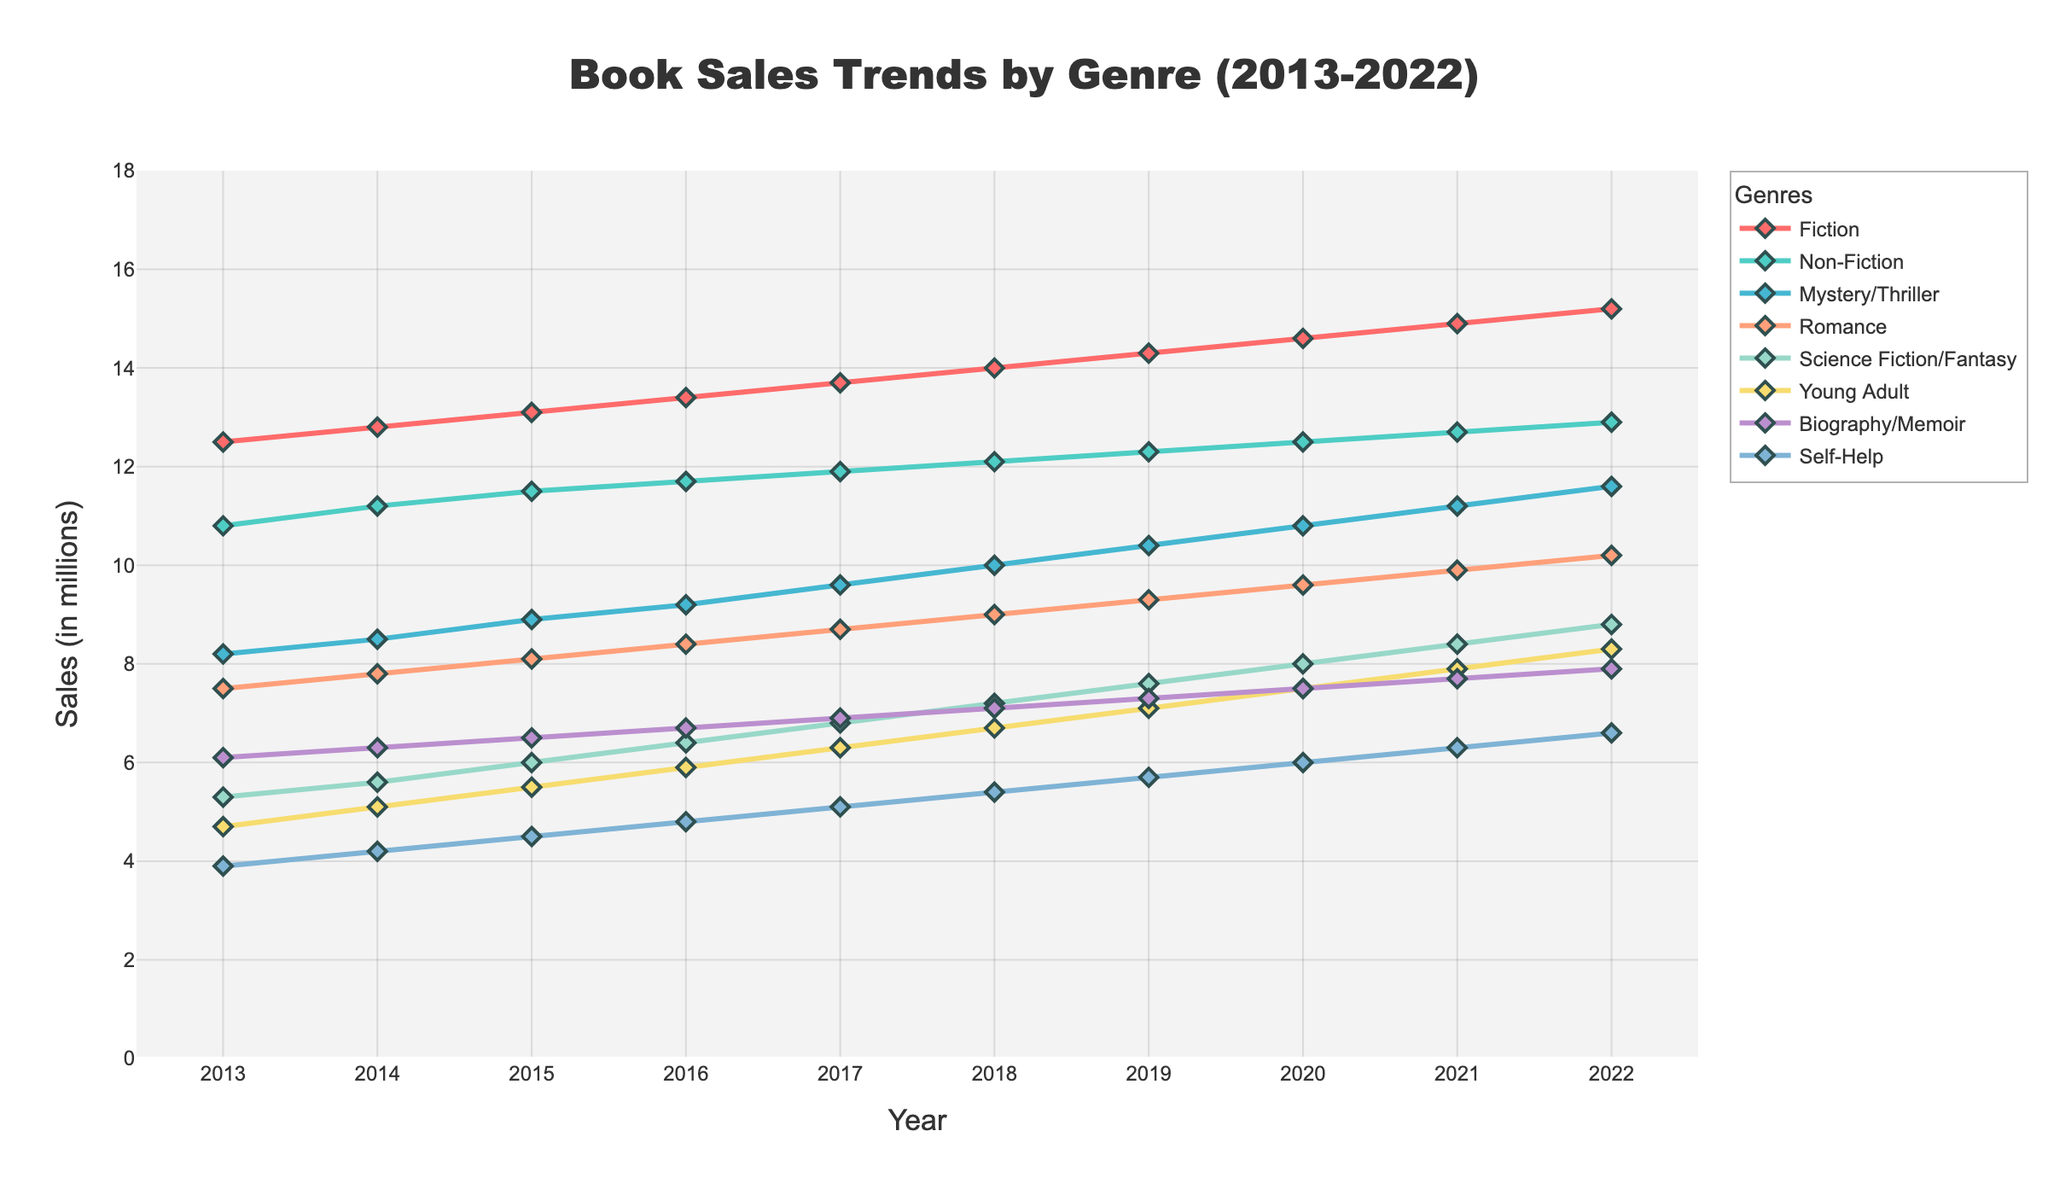What was the total sales of Fiction and Non-Fiction genres in 2020? Add the sales of Fiction and Non-Fiction for the year 2020: 14.6 (Fiction) + 12.5 (Non-Fiction).
Answer: 27.1 Which genre showed the highest sales in 2022? Look at the highest point on the line chart for the year 2022. The Fiction genre has the highest value at 15.2 million sales.
Answer: Fiction Between 2013 and 2022, which genre showed the most consistent growth in sales? Consistent growth would mean a steady increase each year. The Fiction genre increases steadily every year without any fluctuation, indicating consistent growth.
Answer: Fiction How did Romance sales trend from 2013 to 2022? Look at the Romance line over the period. The sales increased every year from 7.5 million in 2013 to 10.2 million in 2022, indicating a positive growth trend.
Answer: Increasing What is the difference in sales between Science Fiction/Fantasy and Romance in 2018? Subtract the sales of Science Fiction/Fantasy from Romance for the year 2018: 9.0 (Romance) - 7.2 (Science Fiction/Fantasy).
Answer: 1.8 Which genre experienced the largest absolute increase in sales from 2013 to 2022? Calculate the difference between 2022 and 2013 sales for each genre, then identify the largest. Fiction increased from 12.5 to 15.2, yielding a growth of 2.7 million, the largest among all genres.
Answer: Fiction Compare the sales trends of Young Adult and Self-Help genres over the decade. Observe the lines for both genres. Both have an upward trend, with Young Adult starting at 4.7 and ending at 8.3, and Self-Help starting at 3.9 and ending at 6.6. Young Adult shows a steeper increase as compared to Self-Help.
Answer: Young Adult increased more Which year did Mystery/Thriller sales surpass 10 million and remained above that level? Look for the year where the Mystery/Thriller line crosses the 10-million mark and stays above that level. This happens in 2018 and continues beyond.
Answer: 2018 Calculate the average sales of the Non-Fiction genre from 2013 to 2022. Add the sales figures from 2013 to 2022 for Non-Fiction and divide by the number of years (10). (10.8 + 11.2 + 11.5 + 11.7 + 11.9 + 12.1 + 12.3 + 12.5 + 12.7 + 12.9) / 10 = 12.16.
Answer: 12.16 